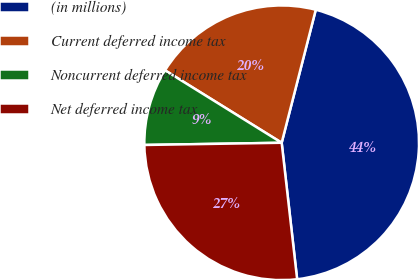Convert chart to OTSL. <chart><loc_0><loc_0><loc_500><loc_500><pie_chart><fcel>(in millions)<fcel>Current deferred income tax<fcel>Noncurrent deferred income tax<fcel>Net deferred income tax<nl><fcel>44.21%<fcel>20.15%<fcel>9.1%<fcel>26.54%<nl></chart> 